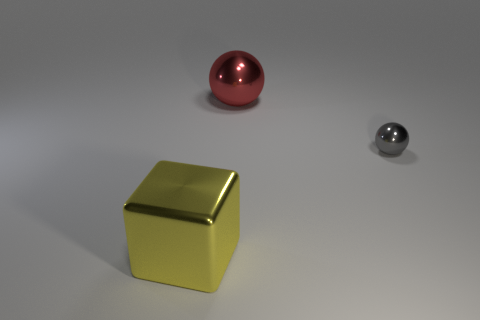What is the material of the large object that is to the right of the yellow metal cube?
Your answer should be very brief. Metal. What number of gray metal things are right of the metal object that is in front of the tiny gray metallic object?
Provide a succinct answer. 1. What number of big red shiny objects have the same shape as the tiny gray metal object?
Offer a very short reply. 1. How many purple shiny things are there?
Your answer should be compact. 0. There is a metallic thing left of the red ball; what is its color?
Offer a terse response. Yellow. What is the color of the metal sphere in front of the big metal thing that is on the right side of the large yellow metallic block?
Your response must be concise. Gray. There is another thing that is the same size as the yellow thing; what color is it?
Your answer should be very brief. Red. What number of metallic things are in front of the tiny sphere and behind the gray shiny thing?
Offer a very short reply. 0. There is a thing that is both behind the yellow cube and in front of the large red metal sphere; what material is it?
Your response must be concise. Metal. Are there fewer tiny gray spheres on the right side of the small gray sphere than big yellow metallic things on the right side of the big red metal thing?
Offer a terse response. No. 